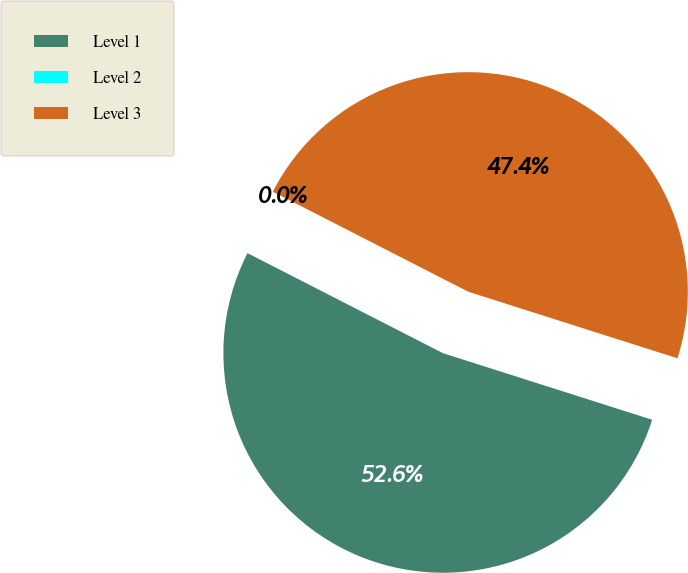<chart> <loc_0><loc_0><loc_500><loc_500><pie_chart><fcel>Level 1<fcel>Level 2<fcel>Level 3<nl><fcel>52.62%<fcel>0.0%<fcel>47.37%<nl></chart> 